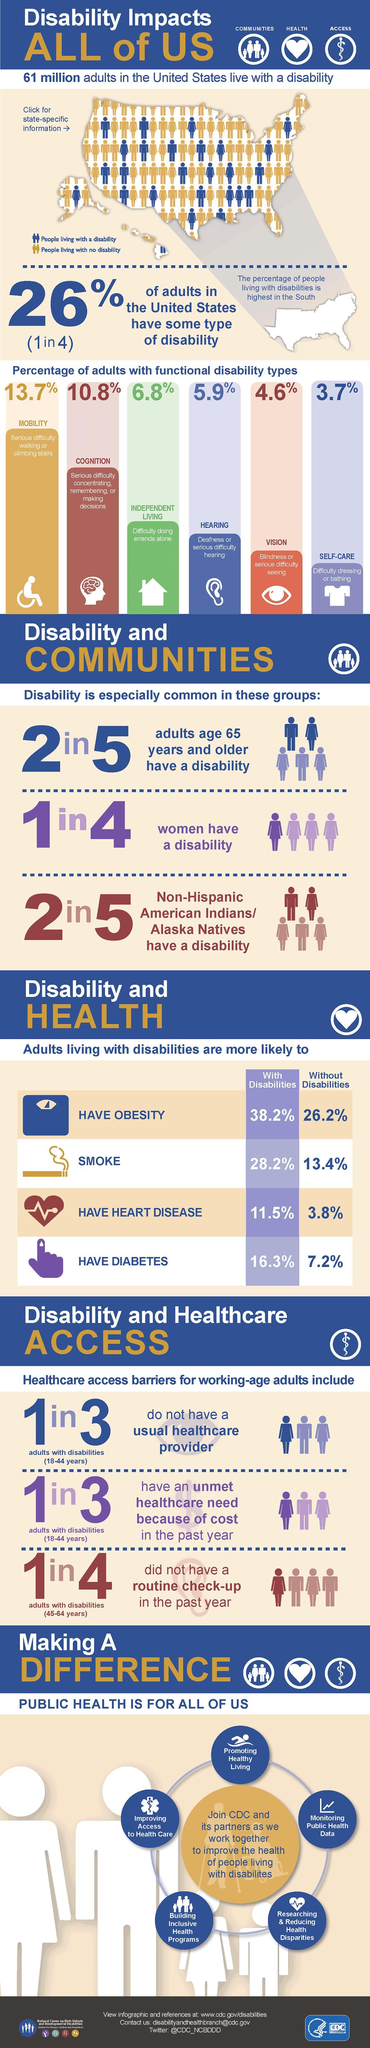What percentage of adults have mobility disability?
Answer the question with a short phrase. 13.7% What percentage of adults have cognitive disability? 10.8% 